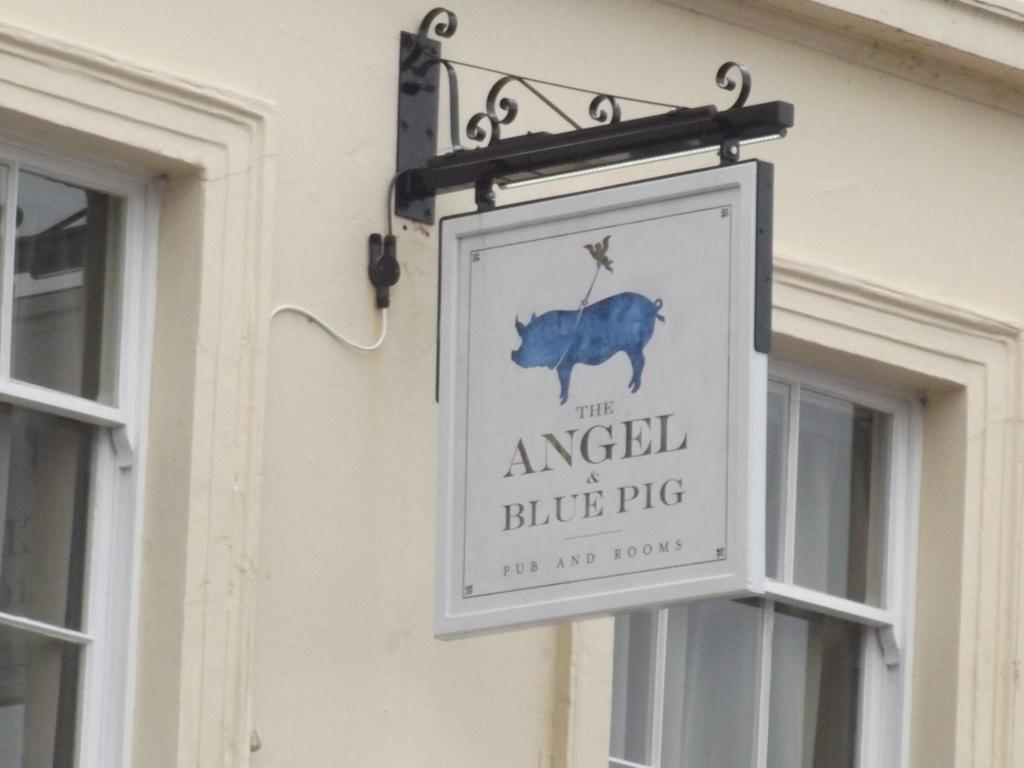What type of structure can be seen in the image? There is a wall in the image. What feature is present on the wall? The wall has windows. What other object is visible in the image? There is a board in the image. What type of advice can be seen written on the wall in the image? There is no advice visible on the wall in the image; it only has windows and is connected to a board. 